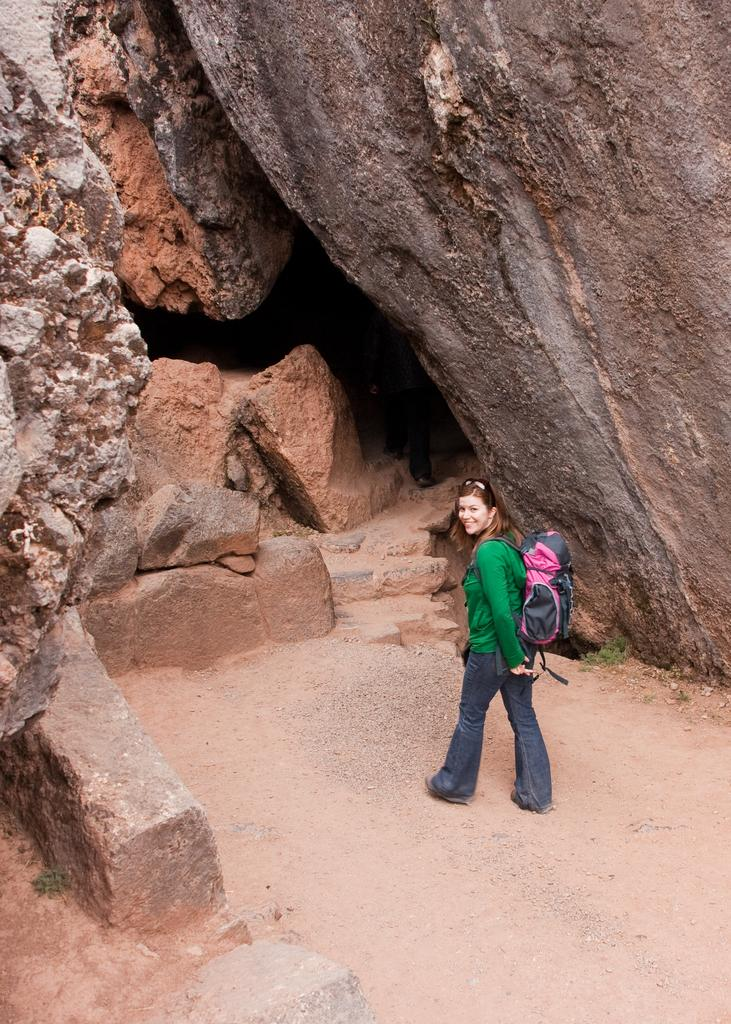What is the primary subject in the image? There is a woman standing in the image. What is the woman wearing on her back? The woman is wearing a backpack. What type of natural features can be seen in the image? There are big rocks in the image. What type of cup is sitting on the furniture in the image? There is no cup or furniture present in the image; it features a woman standing with a backpack and big rocks. 